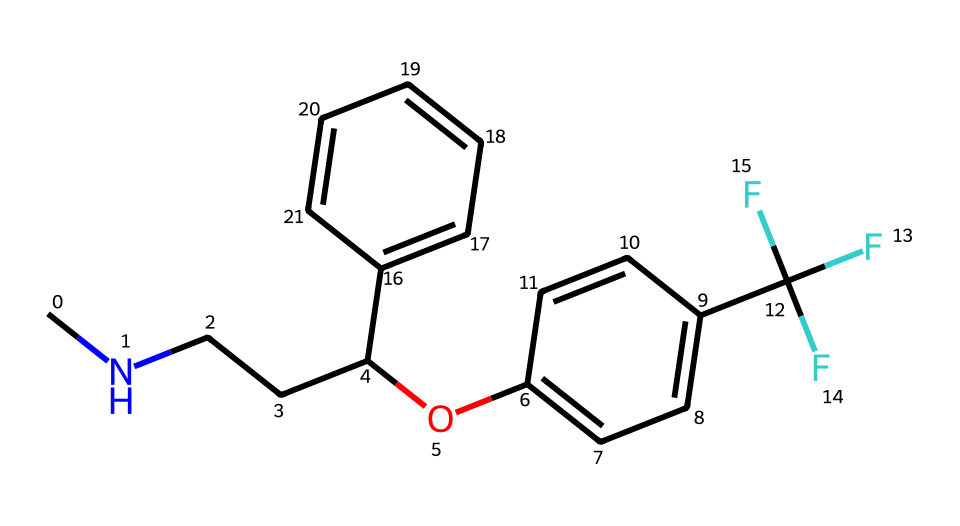What is the primary functional group present in fluoxetine? The primary functional group can be identified by looking for specific atoms and arrangements within the molecule. In this case, fluoxetine contains a hydroxyl (-OH) group, indicated by the presence of "O" followed by "c" in the SMILES representing its attachment to an aromatic ring.
Answer: hydroxyl How many carbon atoms are in the fluoxetine structure? To determine the number of carbon atoms, count all the "C" in the SMILES representation and those implied by the structure, including those in the aromatic rings. The structure has a total of 17 carbon atoms.
Answer: 17 What type of molecule is fluoxetine classified as? Fluoxetine is categorized based on its pharmacological properties as an antidepressant, specifically as a selective serotonin reuptake inhibitor. This classification is derived from its functional properties, even if this isn't explicitly depicted in the chemical structure.
Answer: antidepressant Which part of fluoxetine is responsible for its interaction with serotonin transporters? The side chain of fluoxetine, particularly the amine group ("CN" part), is critical for its biological activity, as it is involved in the inhibition of serotonin reuptake. The nitrogen atom indicates the presence of this amine functionality necessary for binding.
Answer: amine group How many rings are present in the fluoxetine molecule? By analyzing the structure in the SMILES, we observe that there are two distinct aromatic rings present in the molecule. These are identified by the ‘c’ in the notation, indicating aromatic carbon atoms.
Answer: 2 